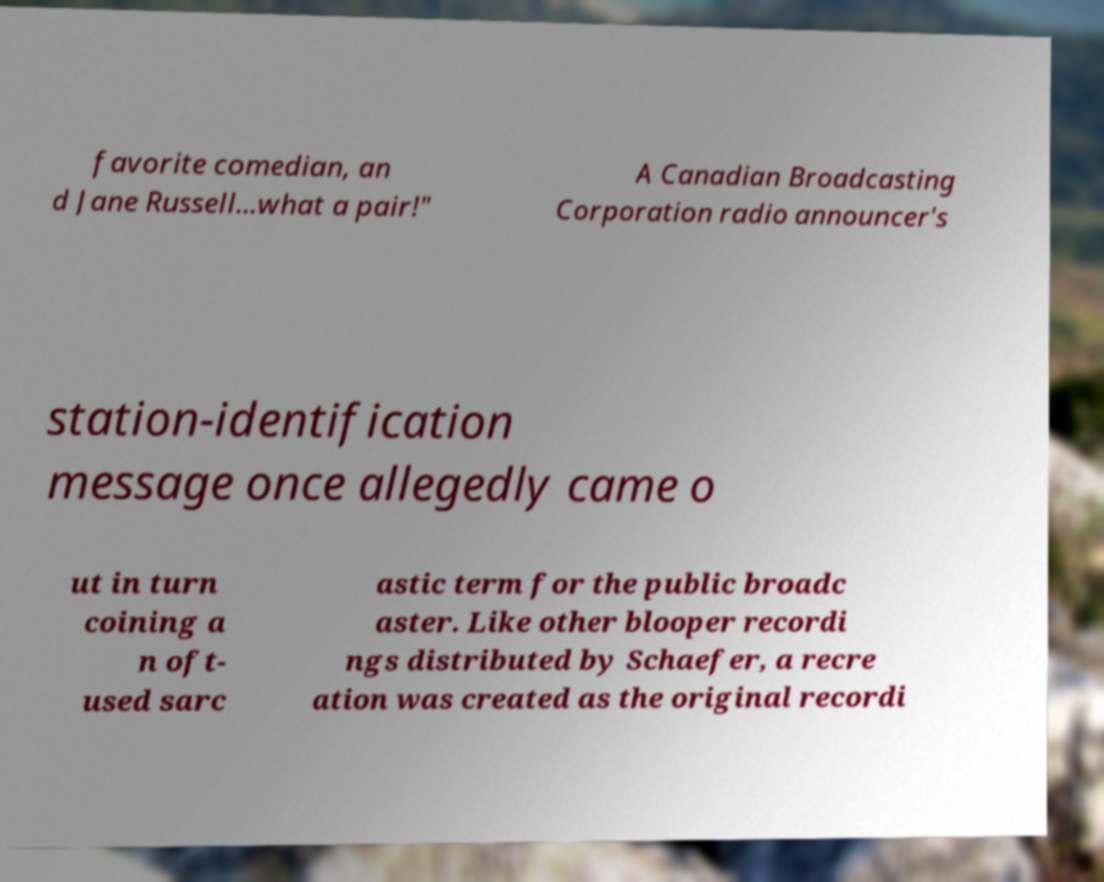Please identify and transcribe the text found in this image. favorite comedian, an d Jane Russell...what a pair!" A Canadian Broadcasting Corporation radio announcer's station-identification message once allegedly came o ut in turn coining a n oft- used sarc astic term for the public broadc aster. Like other blooper recordi ngs distributed by Schaefer, a recre ation was created as the original recordi 